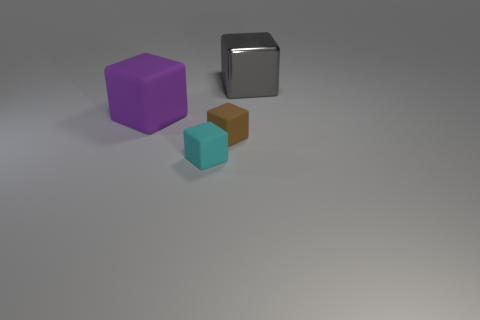Subtract all tiny cyan cubes. How many cubes are left? 3 Add 3 metal things. How many objects exist? 7 Subtract all gray cubes. How many cubes are left? 3 Subtract all green cubes. Subtract all gray balls. How many cubes are left? 4 Subtract all cyan cubes. Subtract all brown matte things. How many objects are left? 2 Add 4 tiny blocks. How many tiny blocks are left? 6 Add 1 tiny purple metallic cylinders. How many tiny purple metallic cylinders exist? 1 Subtract 0 purple balls. How many objects are left? 4 